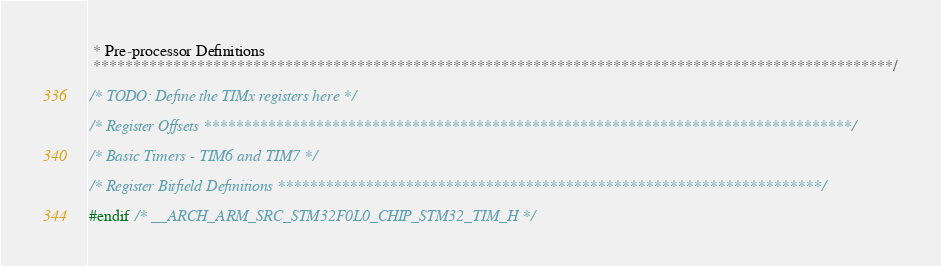<code> <loc_0><loc_0><loc_500><loc_500><_C_> * Pre-processor Definitions
 ****************************************************************************************************/

/* TODO: Define the TIMx registers here */

/* Register Offsets *********************************************************************************/

/* Basic Timers - TIM6 and TIM7 */

/* Register Bitfield Definitions ********************************************************************/

#endif /* __ARCH_ARM_SRC_STM32F0L0_CHIP_STM32_TIM_H */
</code> 